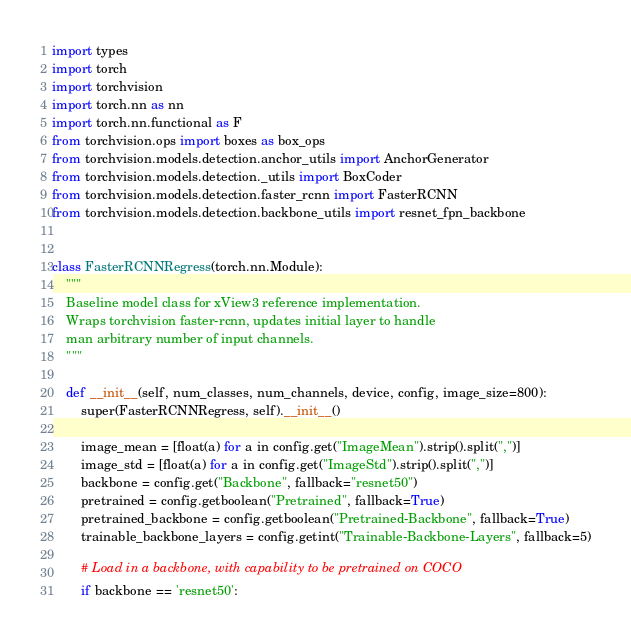Convert code to text. <code><loc_0><loc_0><loc_500><loc_500><_Python_>import types
import torch
import torchvision
import torch.nn as nn
import torch.nn.functional as F
from torchvision.ops import boxes as box_ops
from torchvision.models.detection.anchor_utils import AnchorGenerator
from torchvision.models.detection._utils import BoxCoder
from torchvision.models.detection.faster_rcnn import FasterRCNN
from torchvision.models.detection.backbone_utils import resnet_fpn_backbone


class FasterRCNNRegress(torch.nn.Module):
    """
    Baseline model class for xView3 reference implementation.
    Wraps torchvision faster-rcnn, updates initial layer to handle
    man arbitrary number of input channels.
    """

    def __init__(self, num_classes, num_channels, device, config, image_size=800):
        super(FasterRCNNRegress, self).__init__()

        image_mean = [float(a) for a in config.get("ImageMean").strip().split(",")]
        image_std = [float(a) for a in config.get("ImageStd").strip().split(",")]
        backbone = config.get("Backbone", fallback="resnet50")
        pretrained = config.getboolean("Pretrained", fallback=True)
        pretrained_backbone = config.getboolean("Pretrained-Backbone", fallback=True)
        trainable_backbone_layers = config.getint("Trainable-Backbone-Layers", fallback=5)

        # Load in a backbone, with capability to be pretrained on COCO
        if backbone == 'resnet50':</code> 